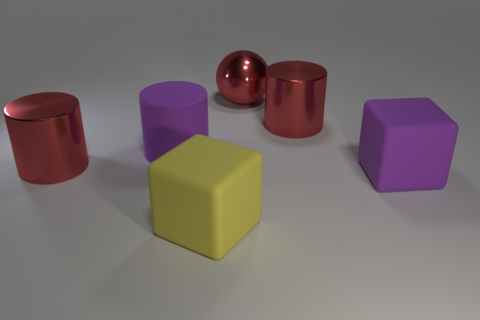Add 4 large spheres. How many objects exist? 10 Subtract all spheres. How many objects are left? 5 Subtract 0 brown cylinders. How many objects are left? 6 Subtract all yellow cubes. Subtract all matte cubes. How many objects are left? 3 Add 6 large red metallic things. How many large red metallic things are left? 9 Add 5 red objects. How many red objects exist? 8 